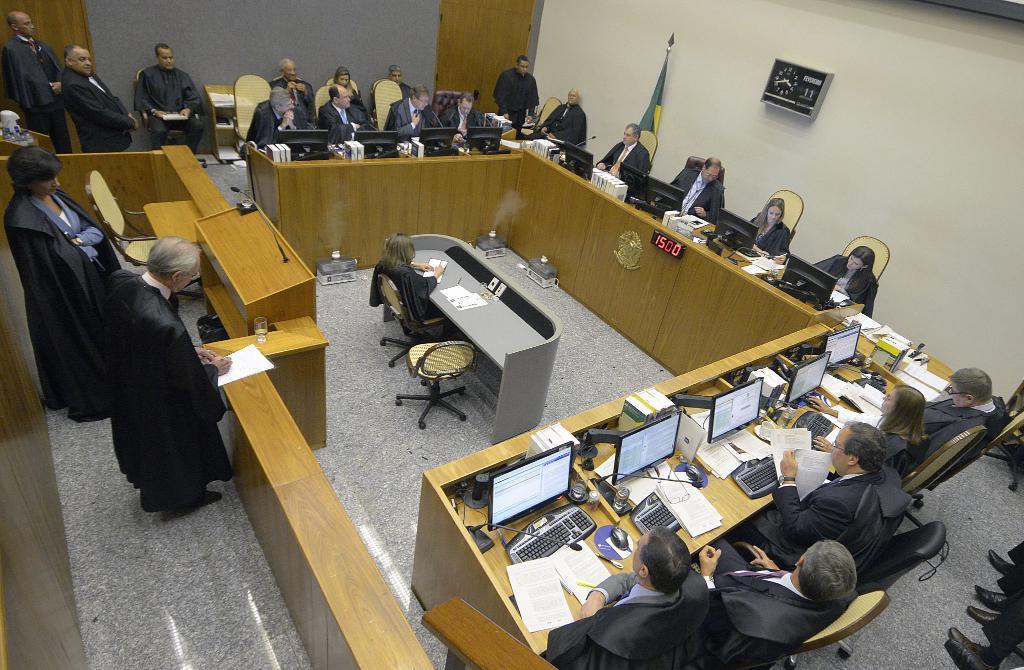Describe this image in one or two sentences. In this image we can see many people sitting on the chairs.. There is a flag. There are many computers and objects placed on the table. There are few people standing in the image. A lady is sitting on the chair at the center of the image. A person is writing on an object at the left side of the image. There is a clock on the wall. There is a digital clock in the image. 